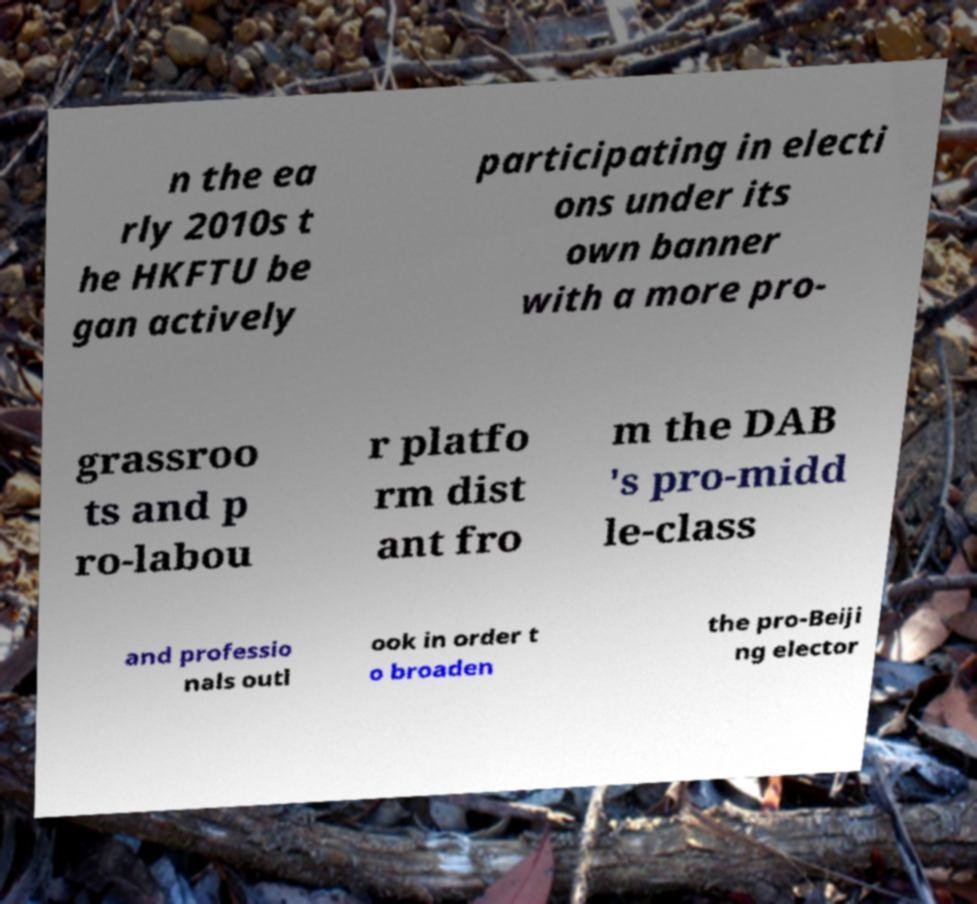I need the written content from this picture converted into text. Can you do that? n the ea rly 2010s t he HKFTU be gan actively participating in electi ons under its own banner with a more pro- grassroo ts and p ro-labou r platfo rm dist ant fro m the DAB 's pro-midd le-class and professio nals outl ook in order t o broaden the pro-Beiji ng elector 